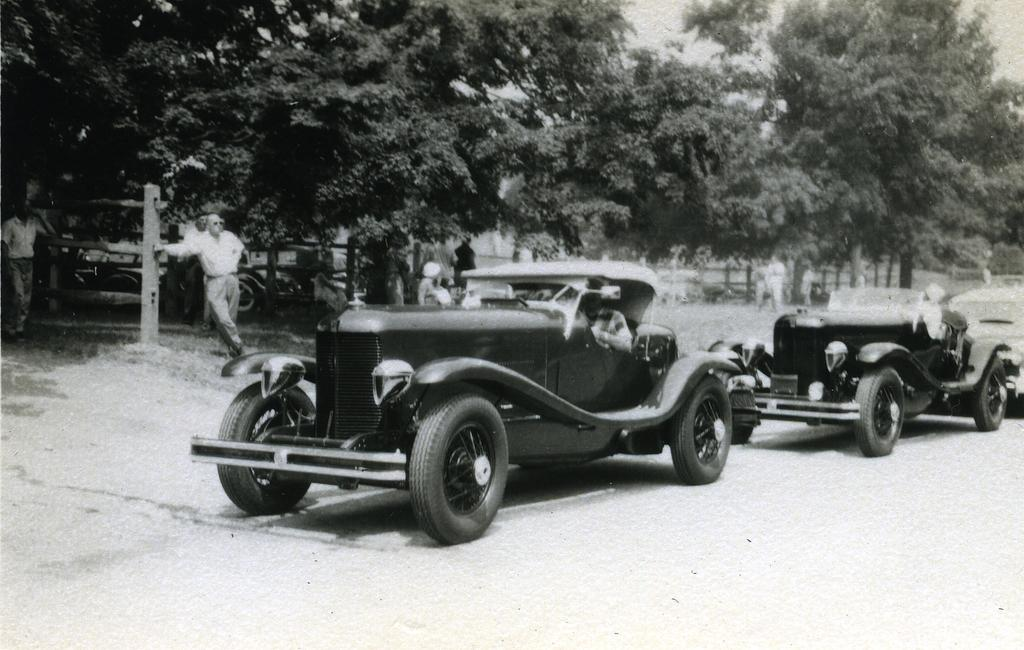What can be seen on the road in the image? There are vehicles parked on the road in the image. What is happening in the background of the image? In the background, there are persons standing under trees. What type of vegetation is covering the ground in the image? The ground is covered with grass in the image. What part of the natural environment is visible in the image? The sky is visible in the background of the image. What type of iron is being used by the persons in the image? There is no iron present in the image; the persons are standing under trees. What kind of apparel is the crow wearing in the image? There is no crow present in the image, and therefore no apparel can be observed. 